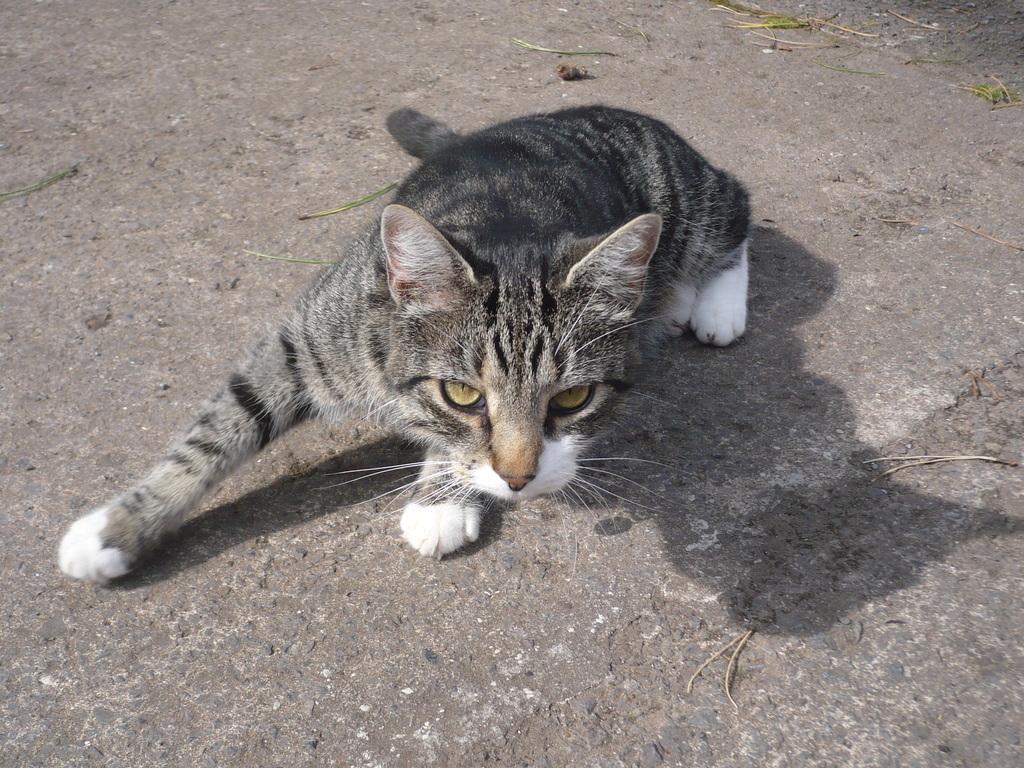In one or two sentences, can you explain what this image depicts? There is a cat in the center of the image. 